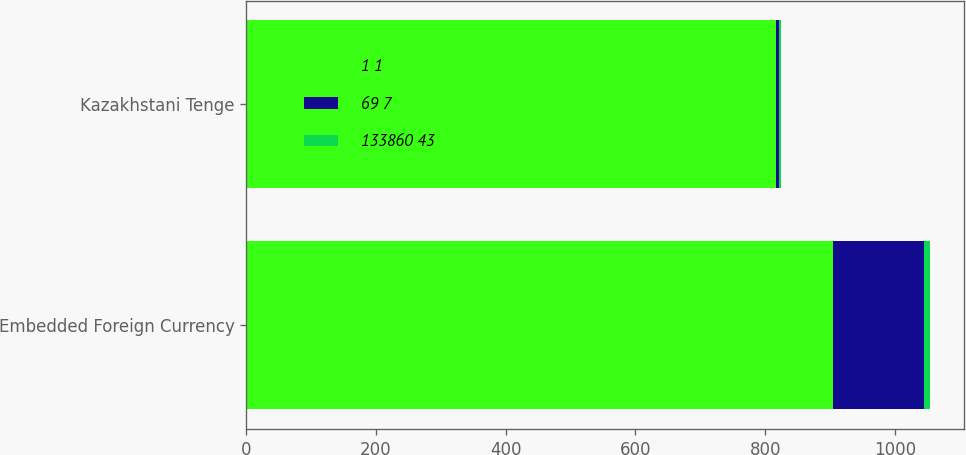Convert chart. <chart><loc_0><loc_0><loc_500><loc_500><stacked_bar_chart><ecel><fcel>Embedded Foreign Currency<fcel>Kazakhstani Tenge<nl><fcel>1 1<fcel>905<fcel>816<nl><fcel>69 7<fcel>139<fcel>5<nl><fcel>133860 43<fcel>10<fcel>4<nl></chart> 